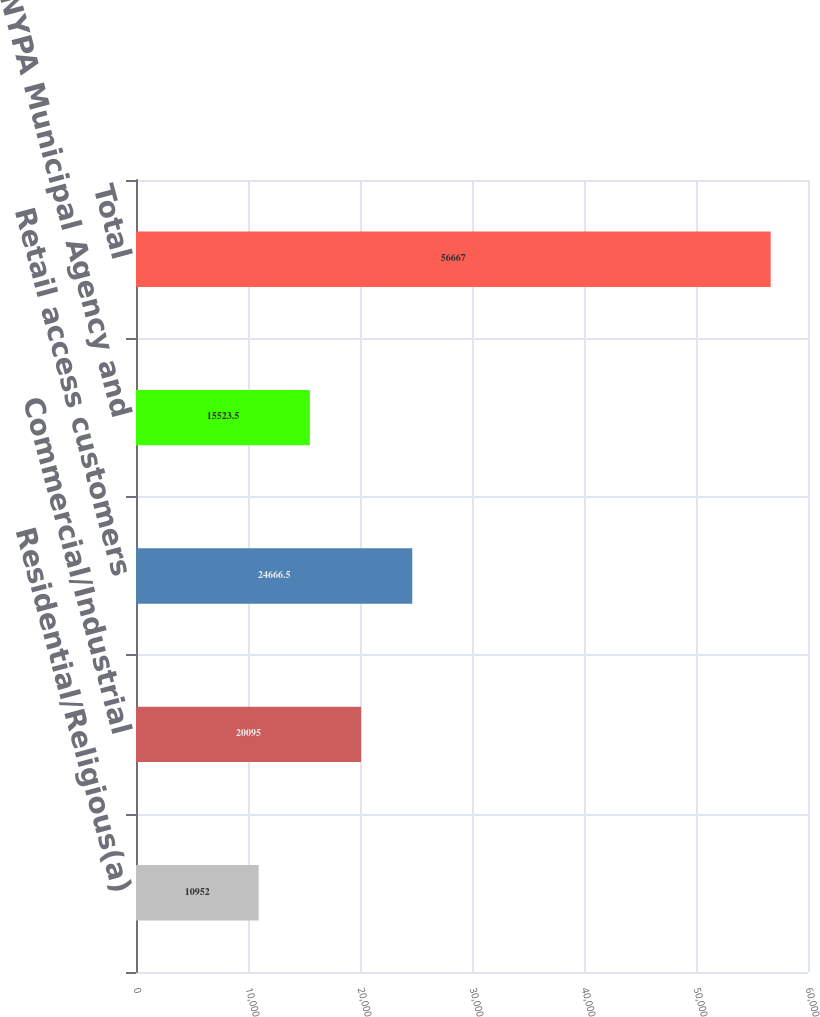<chart> <loc_0><loc_0><loc_500><loc_500><bar_chart><fcel>Residential/Religious(a)<fcel>Commercial/Industrial<fcel>Retail access customers<fcel>NYPA Municipal Agency and<fcel>Total<nl><fcel>10952<fcel>20095<fcel>24666.5<fcel>15523.5<fcel>56667<nl></chart> 